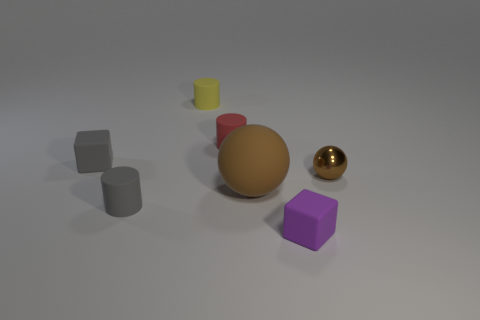Subtract all red rubber cylinders. How many cylinders are left? 2 Add 2 tiny purple matte objects. How many objects exist? 9 Subtract all cubes. How many objects are left? 5 Add 5 gray matte cubes. How many gray matte cubes are left? 6 Add 7 matte blocks. How many matte blocks exist? 9 Subtract 0 green blocks. How many objects are left? 7 Subtract all rubber cylinders. Subtract all cubes. How many objects are left? 2 